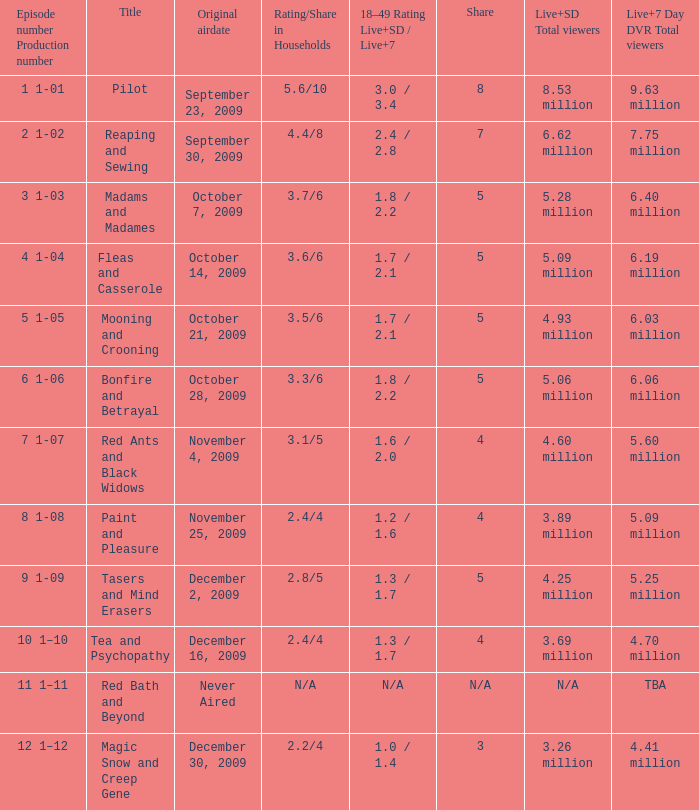When did the episode that had 5.09 million total viewers (both Live and SD types) first air? October 14, 2009. 